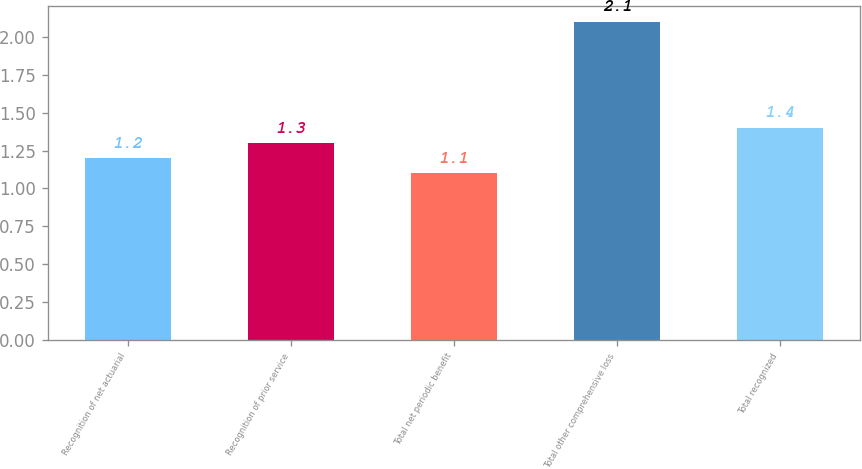Convert chart to OTSL. <chart><loc_0><loc_0><loc_500><loc_500><bar_chart><fcel>Recognition of net actuarial<fcel>Recognition of prior service<fcel>Total net periodic benefit<fcel>Total other comprehensive loss<fcel>Total recognized<nl><fcel>1.2<fcel>1.3<fcel>1.1<fcel>2.1<fcel>1.4<nl></chart> 